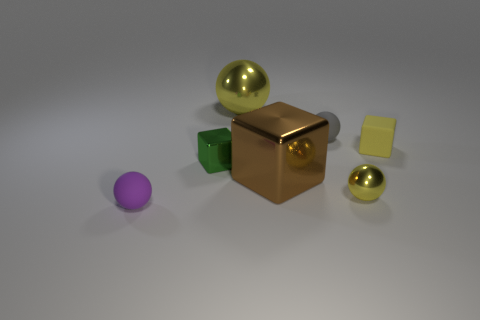Are there any big brown metal cubes to the left of the small purple matte object?
Your answer should be compact. No. There is a big yellow object that is the same shape as the small purple rubber object; what material is it?
Offer a terse response. Metal. Is there any other thing that has the same material as the gray object?
Keep it short and to the point. Yes. What number of other objects are there of the same shape as the large brown object?
Keep it short and to the point. 2. What number of green blocks are behind the yellow ball that is in front of the big shiny thing that is in front of the large yellow metal sphere?
Make the answer very short. 1. What number of tiny gray things are the same shape as the big yellow thing?
Your answer should be very brief. 1. There is a metallic sphere behind the large brown shiny thing; is its color the same as the tiny metal block?
Your answer should be compact. No. What is the shape of the small metal object to the left of the small yellow thing that is left of the yellow matte cube that is behind the green shiny object?
Offer a terse response. Cube. Does the brown shiny cube have the same size as the metallic ball that is in front of the large yellow thing?
Ensure brevity in your answer.  No. Is there a gray matte cylinder that has the same size as the green metallic object?
Offer a very short reply. No. 